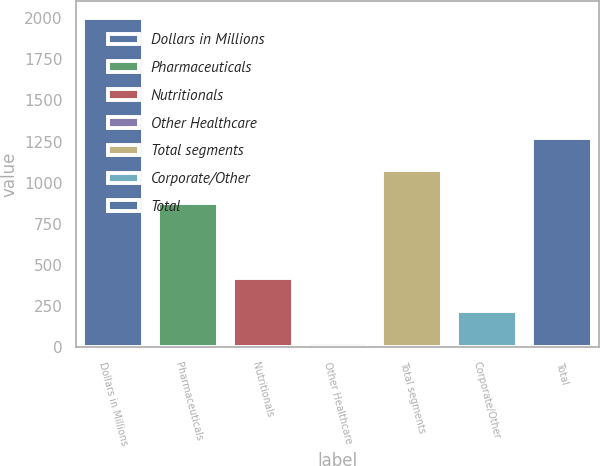<chart> <loc_0><loc_0><loc_500><loc_500><bar_chart><fcel>Dollars in Millions<fcel>Pharmaceuticals<fcel>Nutritionals<fcel>Other Healthcare<fcel>Total segments<fcel>Corporate/Other<fcel>Total<nl><fcel>2002<fcel>878<fcel>420.4<fcel>25<fcel>1075.7<fcel>222.7<fcel>1273.4<nl></chart> 